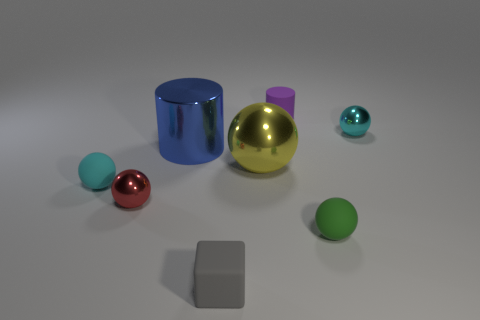Does the blue metallic cylinder have the same size as the green rubber ball? The blue metallic cylinder is taller and appears to have a greater volume than the green rubber ball, indicating that it does not have the same size. 